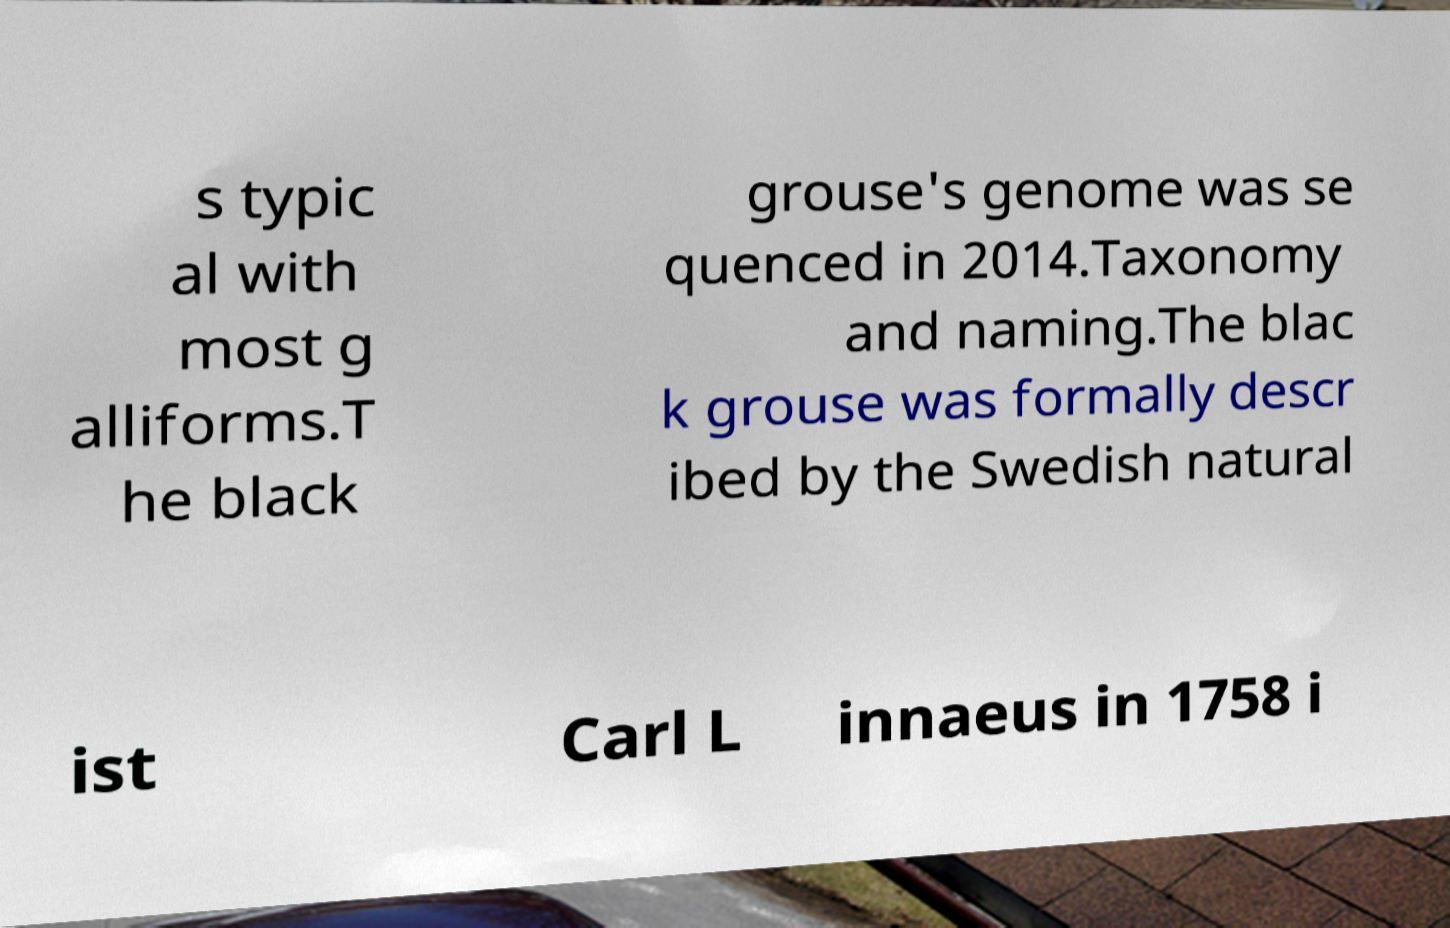Please identify and transcribe the text found in this image. s typic al with most g alliforms.T he black grouse's genome was se quenced in 2014.Taxonomy and naming.The blac k grouse was formally descr ibed by the Swedish natural ist Carl L innaeus in 1758 i 